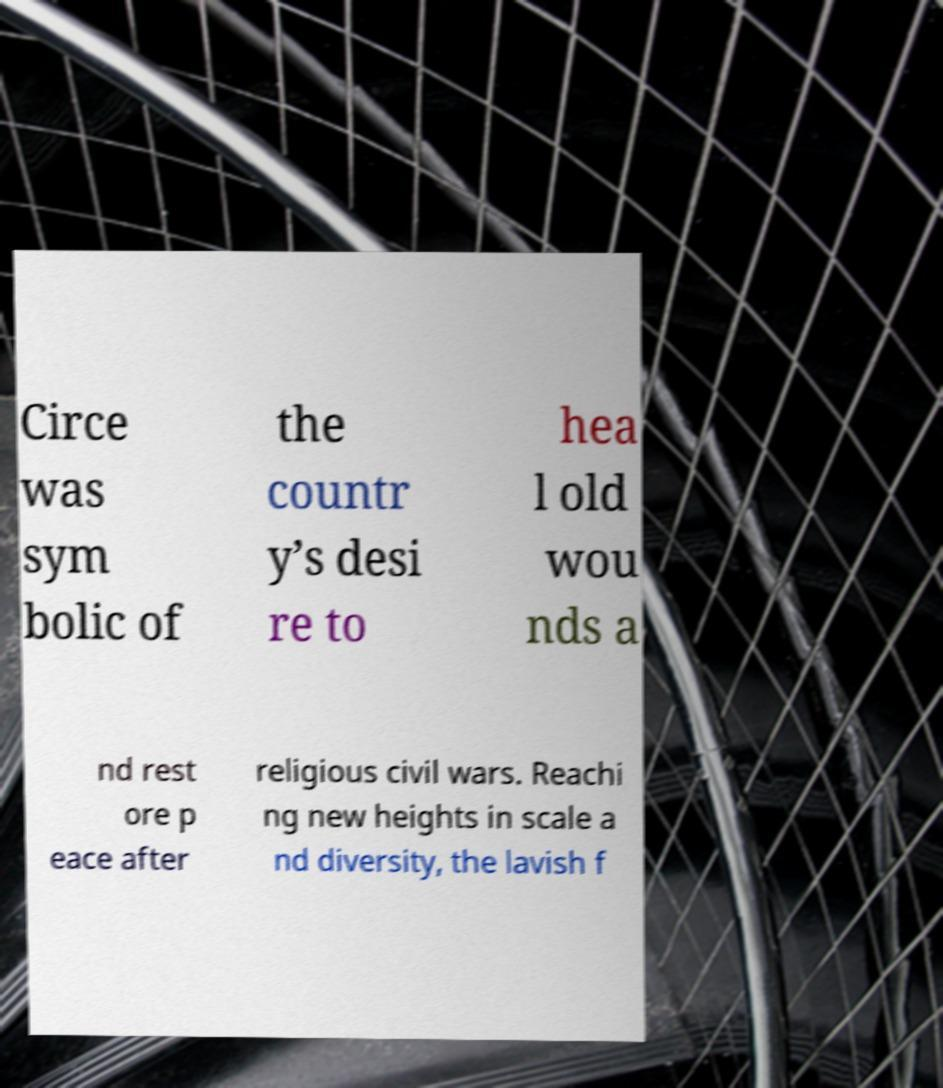For documentation purposes, I need the text within this image transcribed. Could you provide that? Circe was sym bolic of the countr y’s desi re to hea l old wou nds a nd rest ore p eace after religious civil wars. Reachi ng new heights in scale a nd diversity, the lavish f 